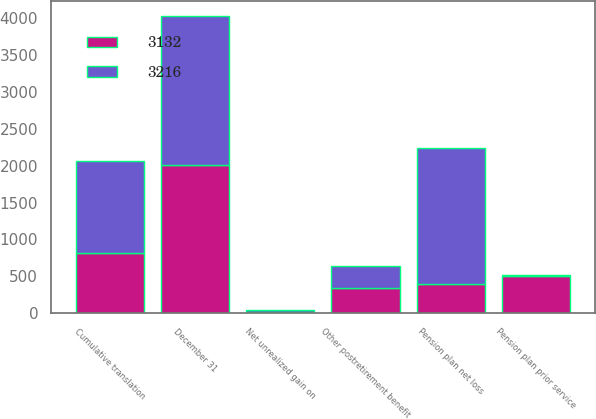Convert chart to OTSL. <chart><loc_0><loc_0><loc_500><loc_500><stacked_bar_chart><ecel><fcel>December 31<fcel>Net unrealized gain on<fcel>Pension plan net loss<fcel>Other postretirement benefit<fcel>Pension plan prior service<fcel>Cumulative translation<nl><fcel>3132<fcel>2011<fcel>21<fcel>402<fcel>347<fcel>502<fcel>811<nl><fcel>3216<fcel>2010<fcel>31<fcel>1837<fcel>295<fcel>15<fcel>1245<nl></chart> 